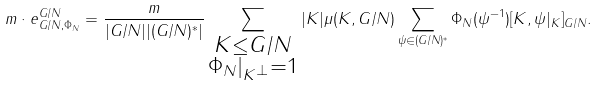<formula> <loc_0><loc_0><loc_500><loc_500>m \cdot e ^ { G / N } _ { G / N , \Phi _ { N } } = \frac { m } { | G / N | | ( G / N ) ^ { * } | } \sum _ { \substack { K \leq G / N \\ \Phi _ { N } | _ { K ^ { \bot } } = 1 } } | K | \mu ( K , G / N ) \sum _ { \psi \in ( G / N ) ^ { * } } \Phi _ { N } ( \psi ^ { - 1 } ) [ K , \psi | _ { K } ] _ { G / N } .</formula> 